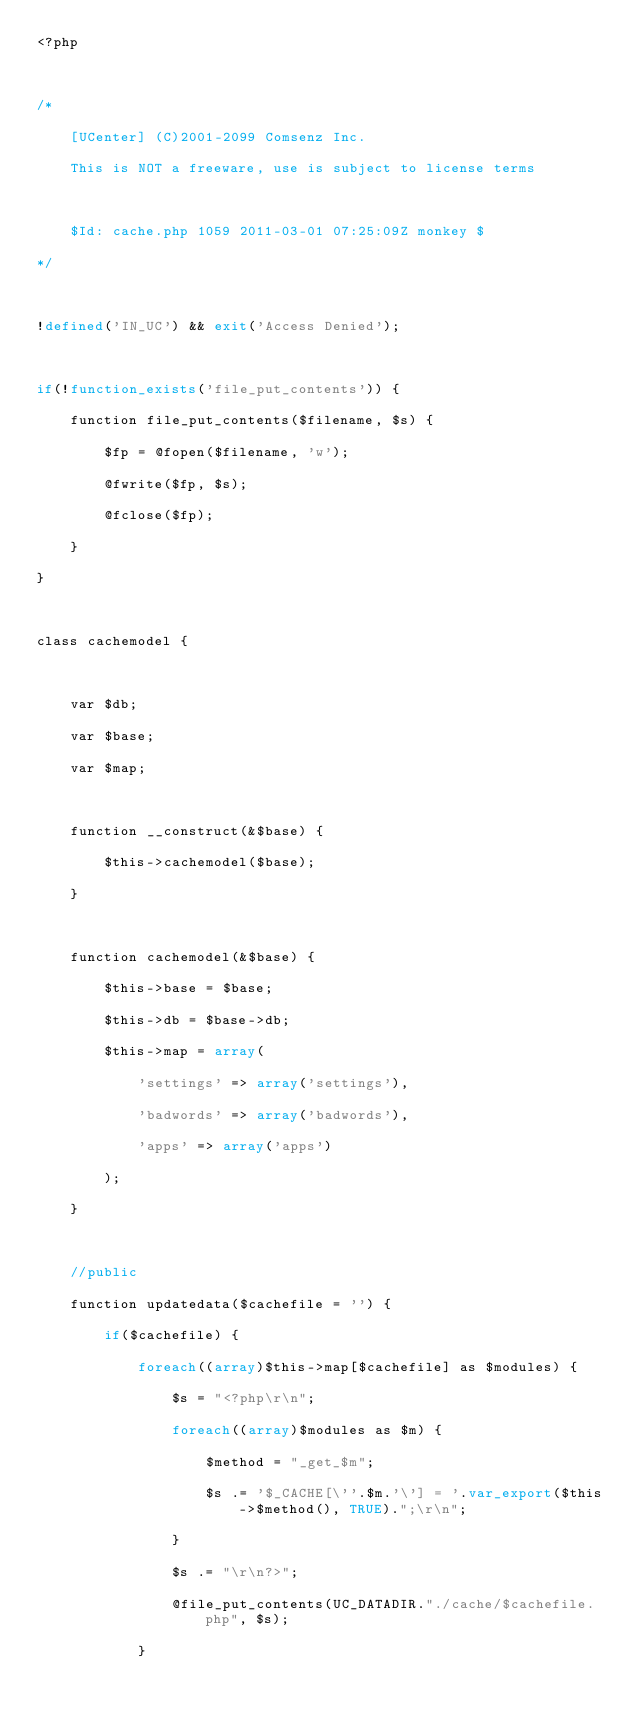Convert code to text. <code><loc_0><loc_0><loc_500><loc_500><_PHP_><?php

/*
	[UCenter] (C)2001-2099 Comsenz Inc.
	This is NOT a freeware, use is subject to license terms

	$Id: cache.php 1059 2011-03-01 07:25:09Z monkey $
*/

!defined('IN_UC') && exit('Access Denied');

if(!function_exists('file_put_contents')) {
	function file_put_contents($filename, $s) {
		$fp = @fopen($filename, 'w');
		@fwrite($fp, $s);
		@fclose($fp);
	}
}

class cachemodel {

	var $db;
	var $base;
	var $map;

	function __construct(&$base) {
		$this->cachemodel($base);
	}

	function cachemodel(&$base) {
		$this->base = $base;
		$this->db = $base->db;
		$this->map = array(
			'settings' => array('settings'),
			'badwords' => array('badwords'),
			'apps' => array('apps')
		);
	}

	//public
	function updatedata($cachefile = '') {
		if($cachefile) {
			foreach((array)$this->map[$cachefile] as $modules) {
				$s = "<?php\r\n";
				foreach((array)$modules as $m) {
					$method = "_get_$m";
					$s .= '$_CACHE[\''.$m.'\'] = '.var_export($this->$method(), TRUE).";\r\n";
				}
				$s .= "\r\n?>";
				@file_put_contents(UC_DATADIR."./cache/$cachefile.php", $s);
			}</code> 